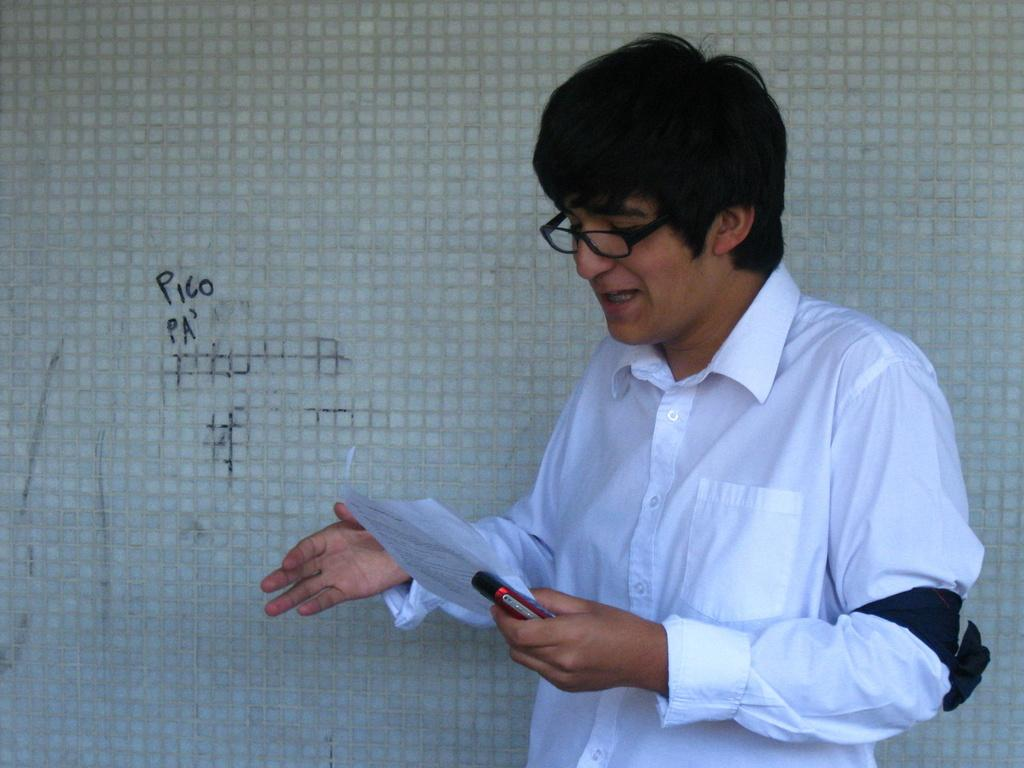Who is present in the image? There is a man in the image. What is the man wearing? The man is wearing a white dress. What accessory is the man wearing? The man is wearing spectacles. What objects is the man holding? The man is holding a mobile phone and a paper. Where is the man standing in the image? The man is standing near a wall. What type of tin can be seen in the man's hand in the image? There is no tin present in the man's hand or in the image. What card game is the man playing in the image? There is no card game or card present in the image. 